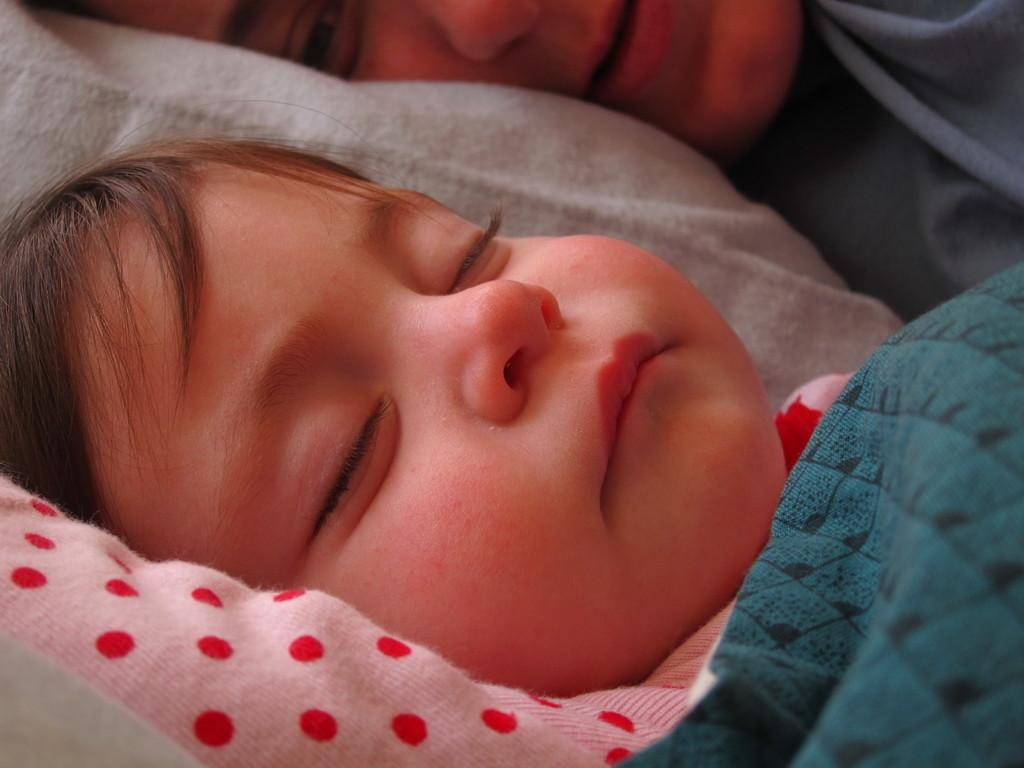What is the main subject of the picture? The main subject of the picture is a baby. Where is the baby located in the image? The baby is sleeping on a bed. What is covering the baby in the image? There is a blue cloth on the baby. Is there anyone else in the picture with the baby? Yes, there is a person laying beside the baby. What type of rice is being cooked by the crow in the image? There is no crow or rice present in the image. What experience does the person laying beside the baby have with babies? The image does not provide any information about the person's experience with babies. 